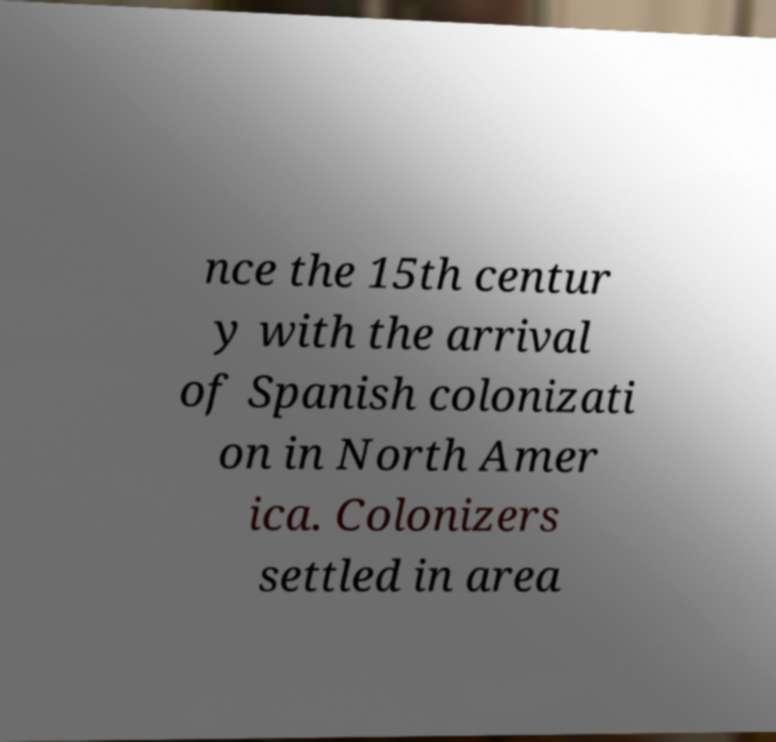Can you accurately transcribe the text from the provided image for me? nce the 15th centur y with the arrival of Spanish colonizati on in North Amer ica. Colonizers settled in area 